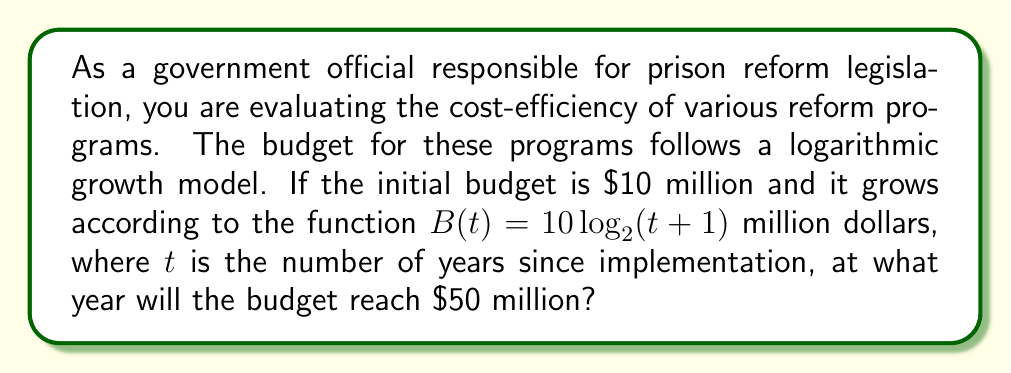Show me your answer to this math problem. To solve this problem, we need to use the given logarithmic function and solve for $t$ when $B(t) = 50$. Let's approach this step-by-step:

1) We start with the equation:
   $B(t) = 10 \log_2(t+1)$

2) We want to find $t$ when $B(t) = 50$, so we set up the equation:
   $50 = 10 \log_2(t+1)$

3) Divide both sides by 10:
   $5 = \log_2(t+1)$

4) To solve for $t$, we need to apply the inverse function of $\log_2$, which is $2^x$:
   $2^5 = t+1$

5) Calculate $2^5$:
   $32 = t+1$

6) Subtract 1 from both sides:
   $31 = t$

7) Since $t$ represents years, we need to round up to the nearest whole number, as the budget will reach $50 million during the 32nd year.
Answer: The budget will reach $50 million in the 32nd year after implementation of the reform programs. 